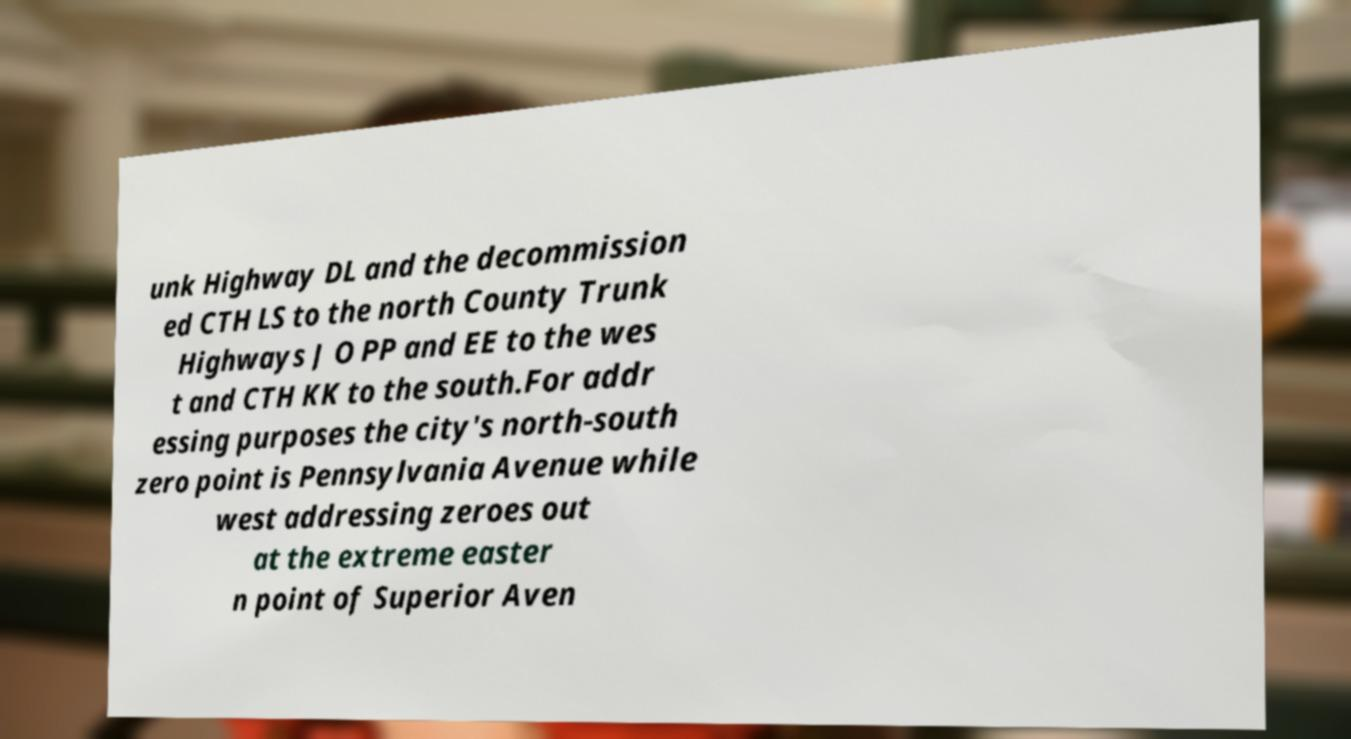Could you extract and type out the text from this image? unk Highway DL and the decommission ed CTH LS to the north County Trunk Highways J O PP and EE to the wes t and CTH KK to the south.For addr essing purposes the city's north-south zero point is Pennsylvania Avenue while west addressing zeroes out at the extreme easter n point of Superior Aven 